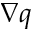Convert formula to latex. <formula><loc_0><loc_0><loc_500><loc_500>\nabla q</formula> 